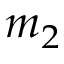<formula> <loc_0><loc_0><loc_500><loc_500>m _ { 2 }</formula> 